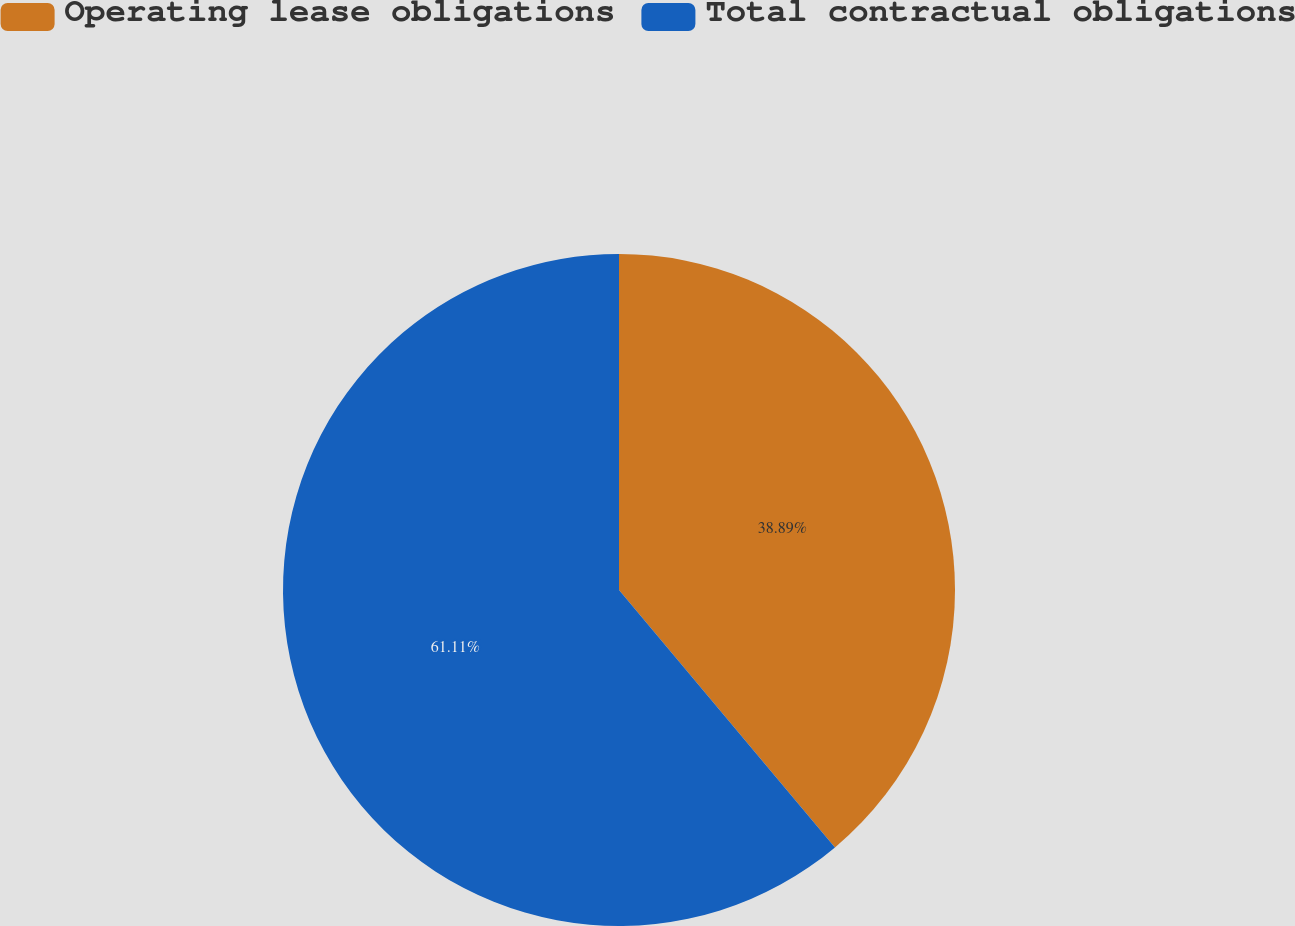Convert chart to OTSL. <chart><loc_0><loc_0><loc_500><loc_500><pie_chart><fcel>Operating lease obligations<fcel>Total contractual obligations<nl><fcel>38.89%<fcel>61.11%<nl></chart> 